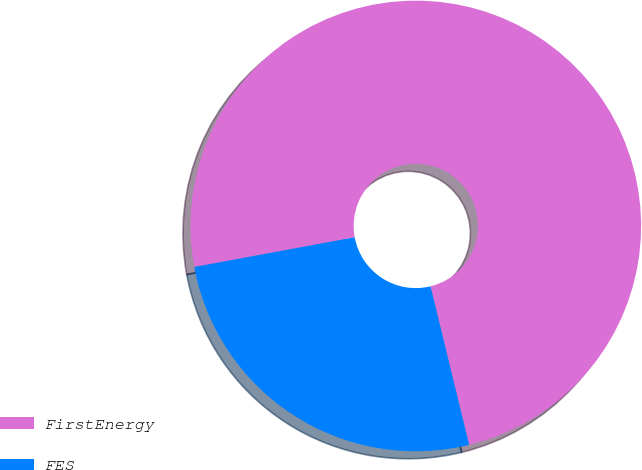Convert chart to OTSL. <chart><loc_0><loc_0><loc_500><loc_500><pie_chart><fcel>FirstEnergy<fcel>FES<nl><fcel>74.11%<fcel>25.89%<nl></chart> 